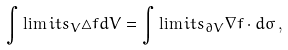<formula> <loc_0><loc_0><loc_500><loc_500>\int \lim i t s _ { V } \triangle f d V = \int \lim i t s _ { \partial V } \nabla f \cdot d \sigma \, ,</formula> 